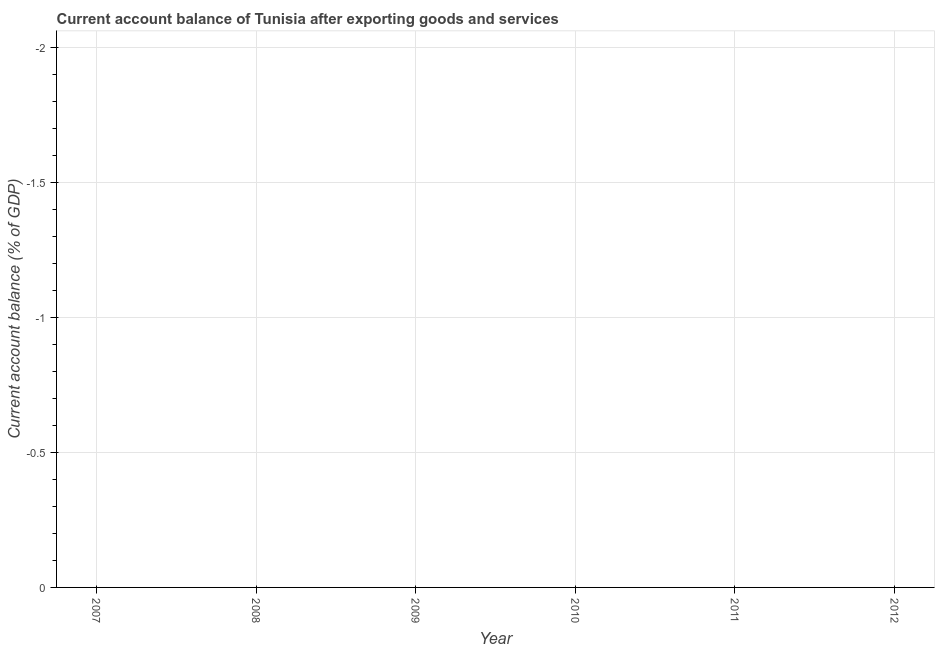What is the current account balance in 2008?
Make the answer very short. 0. What is the average current account balance per year?
Provide a short and direct response. 0. Does the current account balance monotonically increase over the years?
Your answer should be very brief. No. How many dotlines are there?
Your answer should be very brief. 0. How many years are there in the graph?
Keep it short and to the point. 6. What is the difference between two consecutive major ticks on the Y-axis?
Provide a succinct answer. 0.5. Are the values on the major ticks of Y-axis written in scientific E-notation?
Make the answer very short. No. Does the graph contain any zero values?
Give a very brief answer. Yes. Does the graph contain grids?
Provide a short and direct response. Yes. What is the title of the graph?
Provide a short and direct response. Current account balance of Tunisia after exporting goods and services. What is the label or title of the Y-axis?
Provide a succinct answer. Current account balance (% of GDP). What is the Current account balance (% of GDP) in 2008?
Your response must be concise. 0. What is the Current account balance (% of GDP) in 2012?
Provide a short and direct response. 0. 